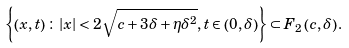Convert formula to latex. <formula><loc_0><loc_0><loc_500><loc_500>\left \{ \left ( x , t \right ) \colon \left | x \right | < 2 \sqrt { c + 3 \delta + \eta \delta ^ { 2 } } , t \in \left ( 0 , \delta \right ) \right \} \subset F _ { 2 } \left ( c , \delta \right ) .</formula> 